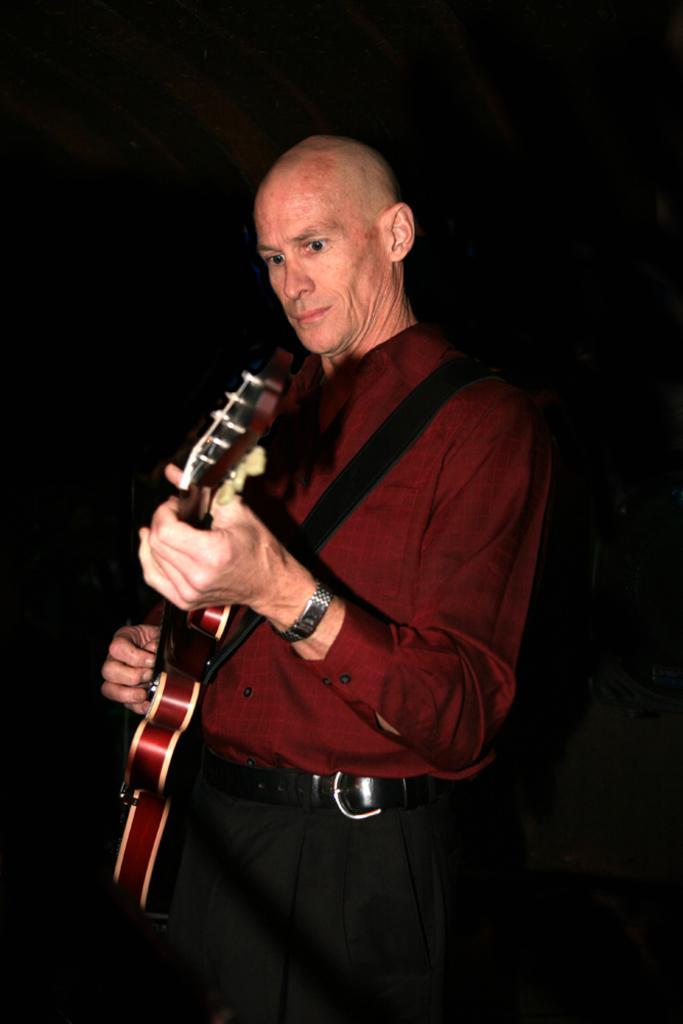Describe this image in one or two sentences. He is standing. He's holding a guitar. He's wearing a watch and belt. 